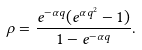<formula> <loc_0><loc_0><loc_500><loc_500>\rho = \frac { e ^ { - \alpha q } ( e ^ { \alpha q ^ { 2 } } - 1 ) } { 1 - e ^ { - \alpha q } } .</formula> 